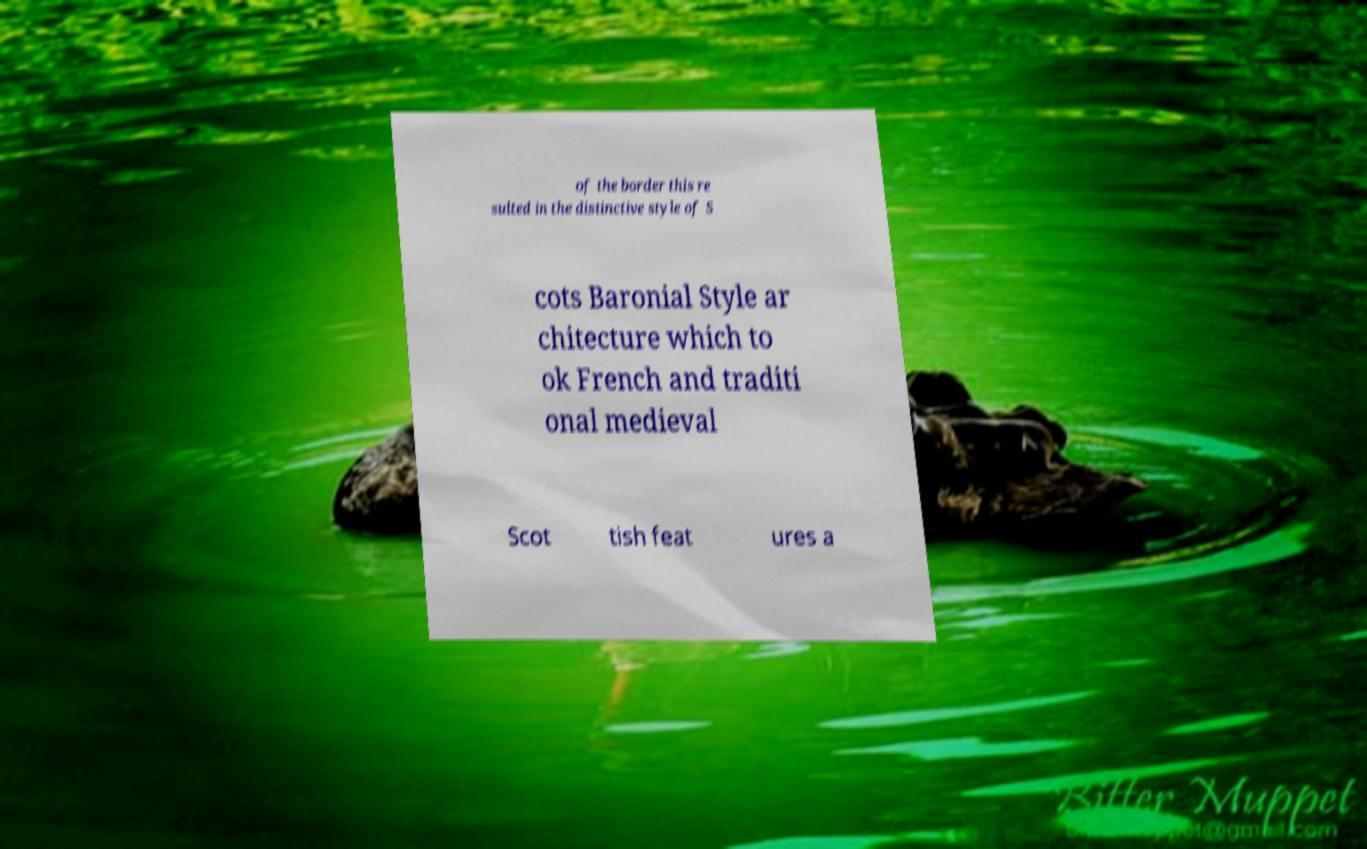Could you assist in decoding the text presented in this image and type it out clearly? of the border this re sulted in the distinctive style of S cots Baronial Style ar chitecture which to ok French and traditi onal medieval Scot tish feat ures a 